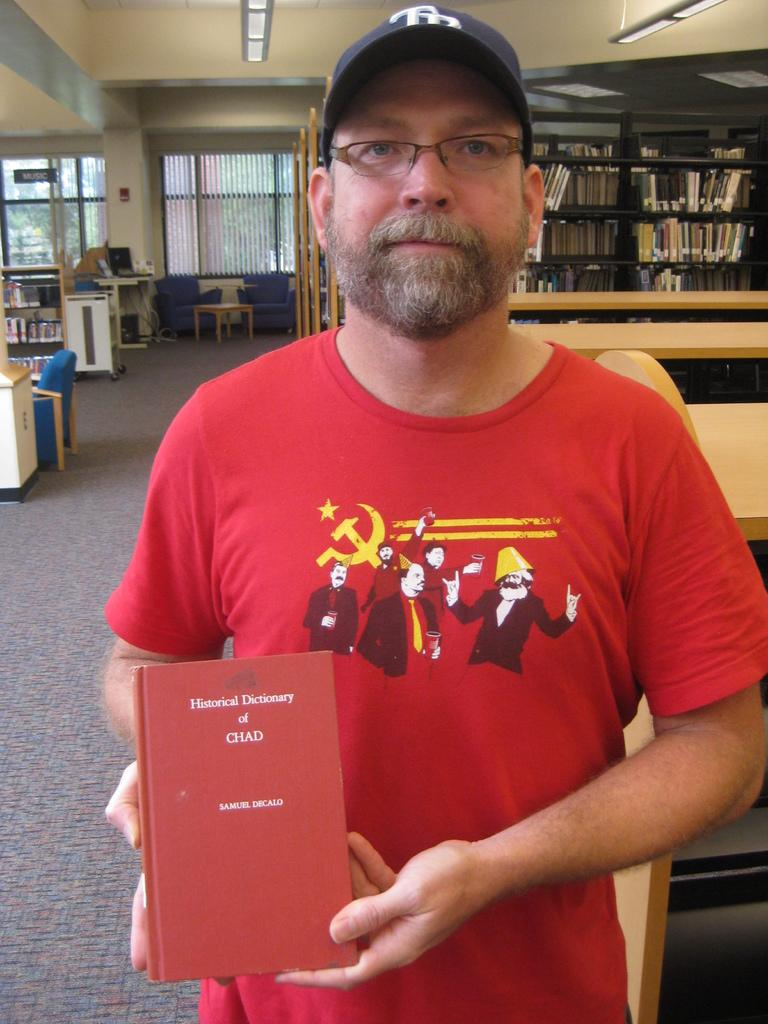<image>
Summarize the visual content of the image. A man wearing a red shirt holds a Historical Dictionary of Chad book. 